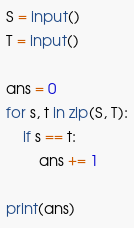<code> <loc_0><loc_0><loc_500><loc_500><_Python_>S = input()
T = input()

ans = 0
for s, t in zip(S, T):
    if s == t:
        ans += 1

print(ans)
</code> 